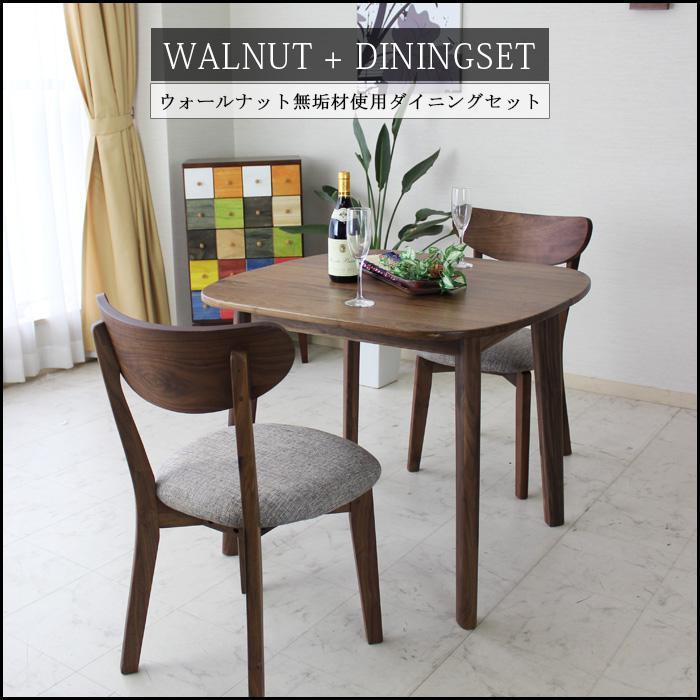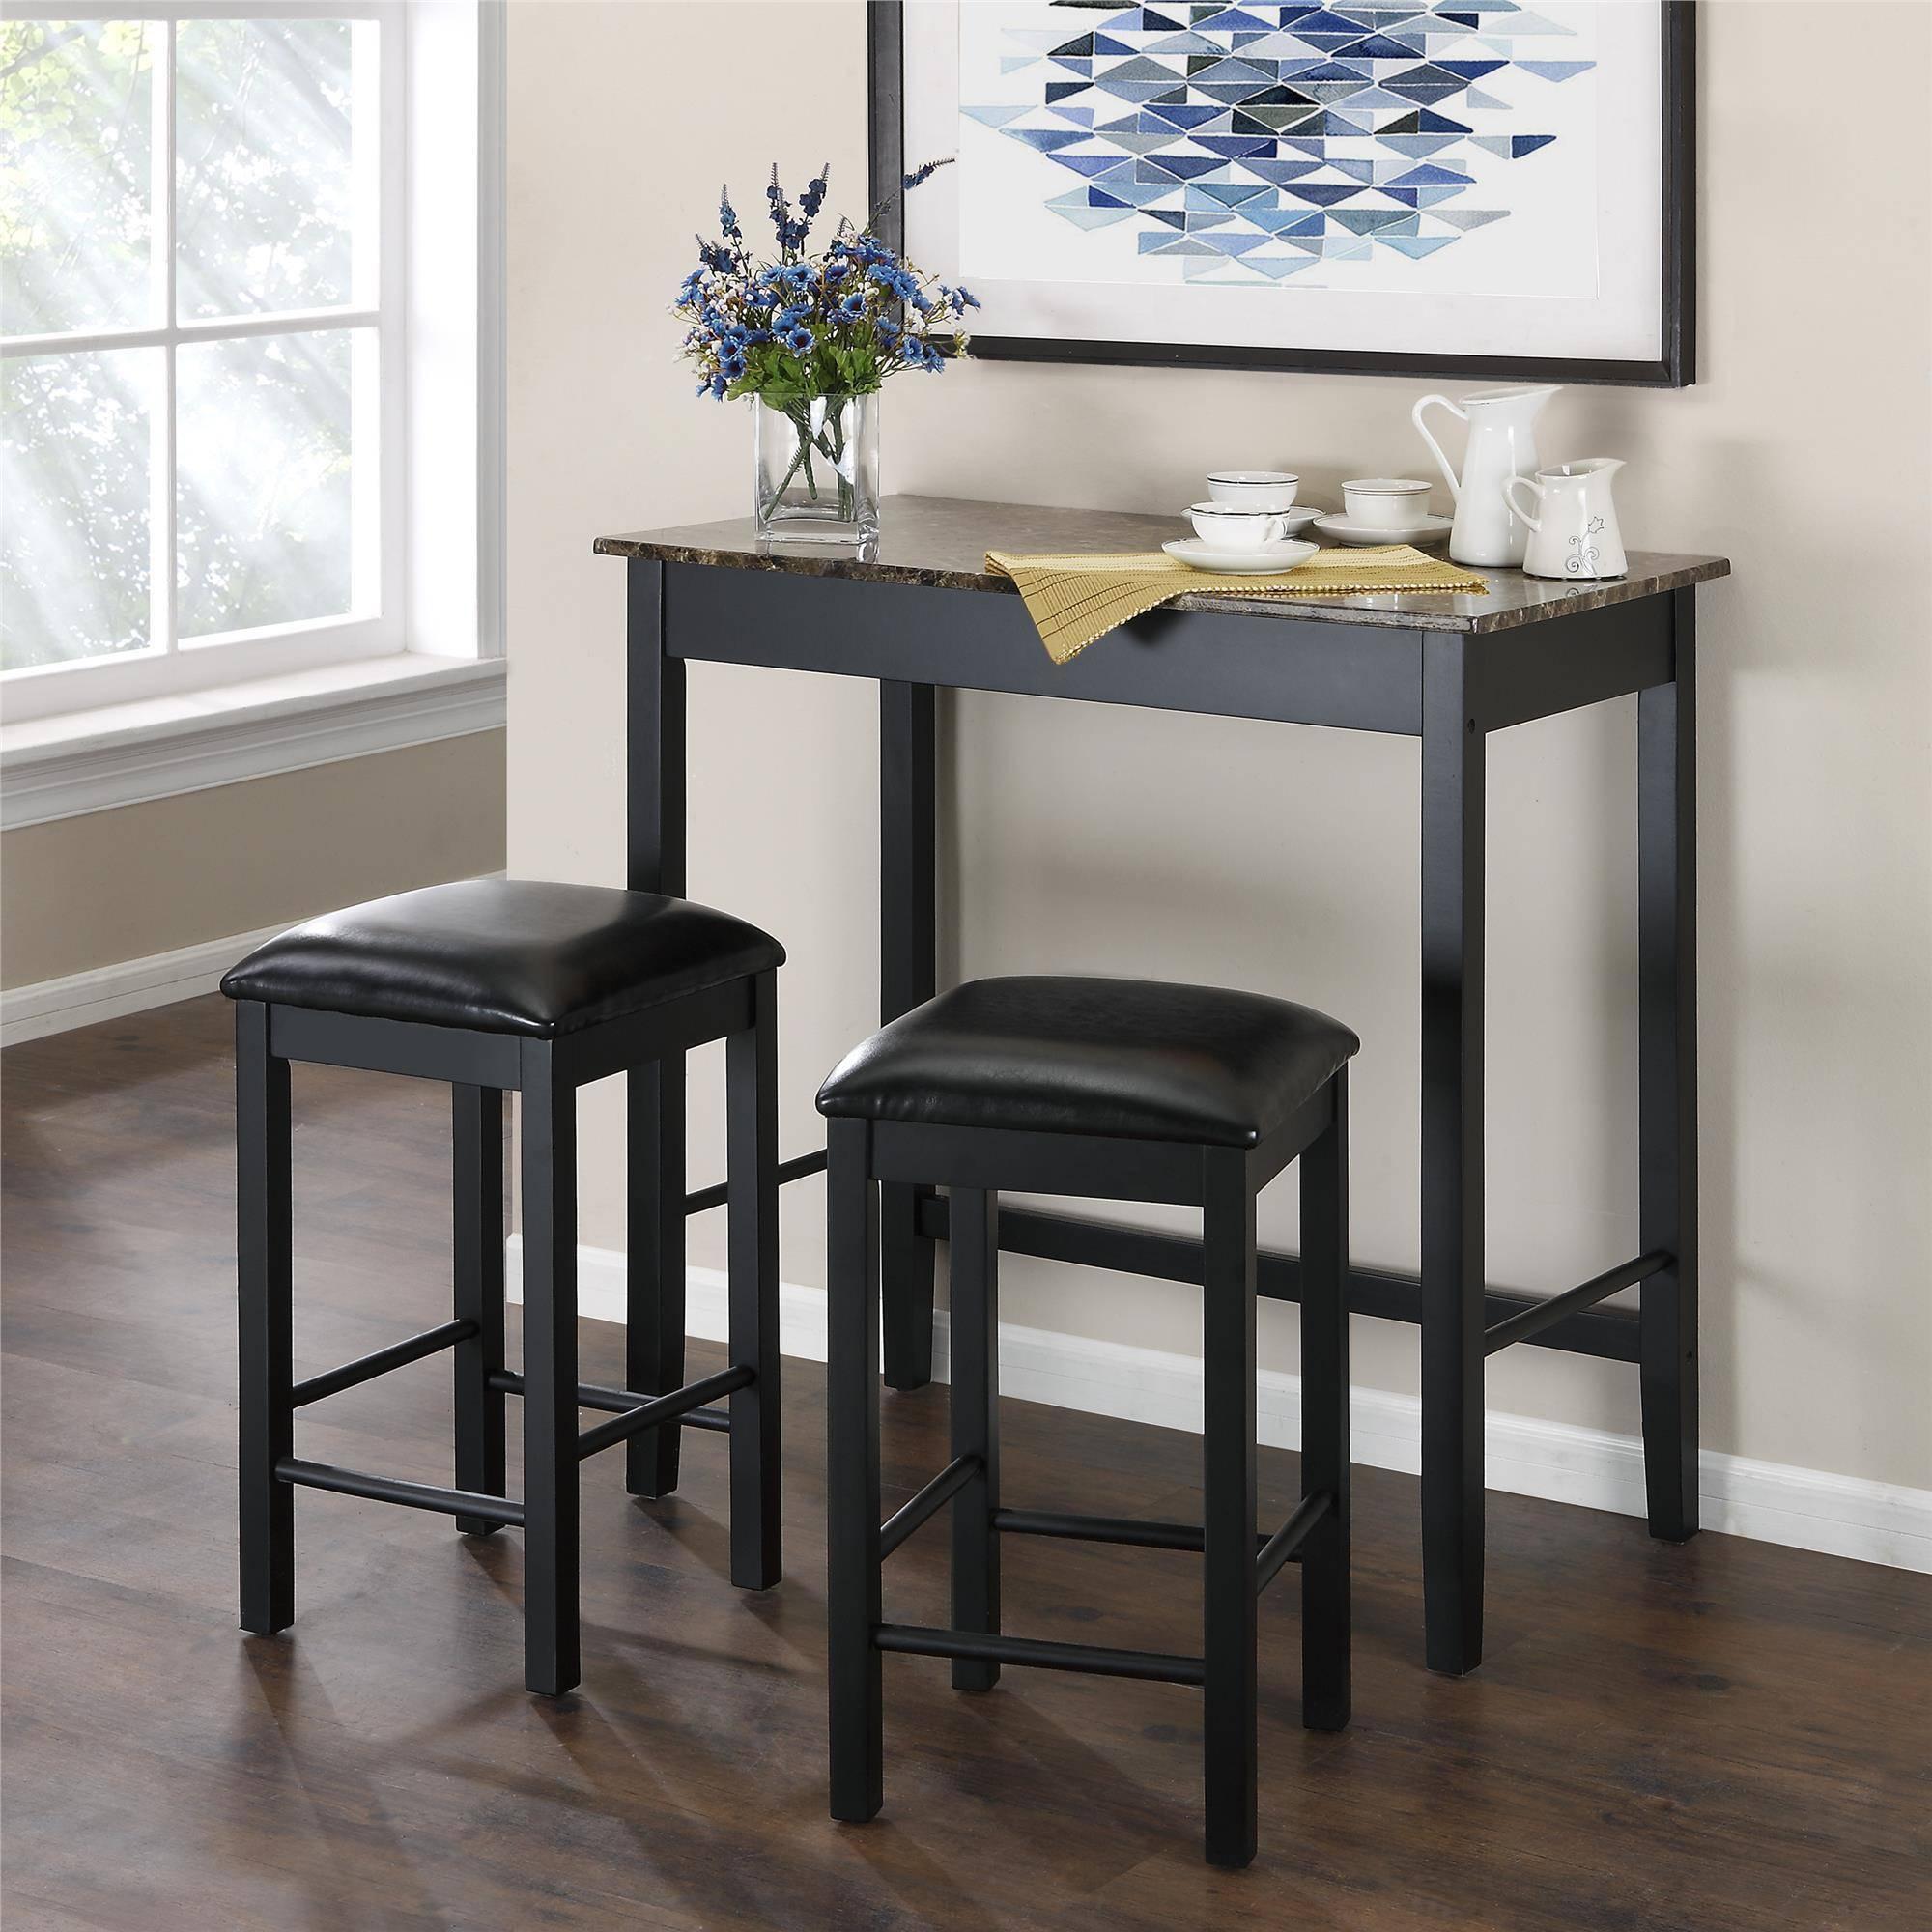The first image is the image on the left, the second image is the image on the right. Given the left and right images, does the statement "One of the images shows a high top table with stools." hold true? Answer yes or no. Yes. 